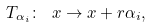<formula> <loc_0><loc_0><loc_500><loc_500>T _ { { \alpha } _ { i } } \colon \ { x } \to { x } + r { \alpha } _ { i } ,</formula> 